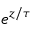Convert formula to latex. <formula><loc_0><loc_0><loc_500><loc_500>e ^ { z / \tau }</formula> 